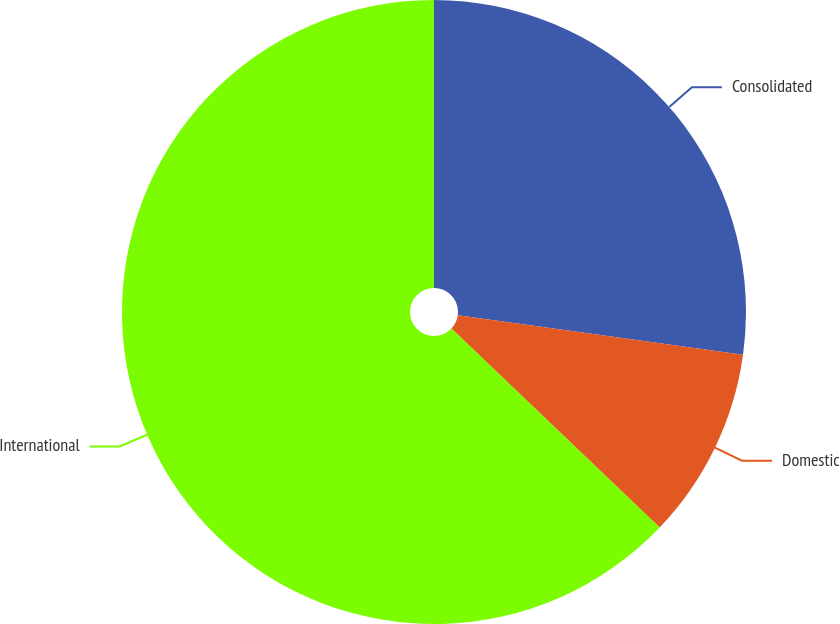Convert chart. <chart><loc_0><loc_0><loc_500><loc_500><pie_chart><fcel>Consolidated<fcel>Domestic<fcel>International<nl><fcel>27.19%<fcel>9.94%<fcel>62.87%<nl></chart> 